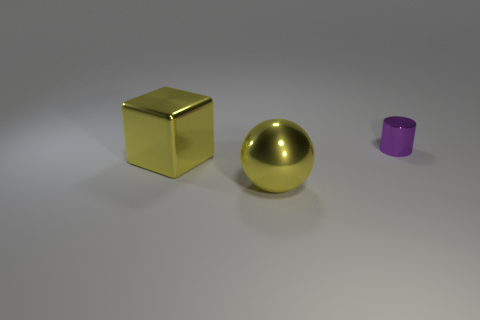What number of other objects are the same color as the tiny object?
Your answer should be very brief. 0. What material is the block?
Provide a short and direct response. Metal. What is the object that is both right of the metal block and in front of the metal cylinder made of?
Offer a terse response. Metal. How many objects are either things in front of the cylinder or large blocks?
Your answer should be compact. 2. Is the large metallic block the same color as the big ball?
Offer a terse response. Yes. Is there a yellow metallic cube that has the same size as the yellow sphere?
Keep it short and to the point. Yes. What number of metallic objects are both behind the big block and on the left side of the tiny purple cylinder?
Your answer should be compact. 0. There is a purple cylinder; what number of blocks are behind it?
Ensure brevity in your answer.  0. There is a small purple thing; is it the same shape as the object that is in front of the yellow cube?
Your response must be concise. No. What number of cubes are either yellow rubber objects or purple shiny things?
Your answer should be compact. 0. 